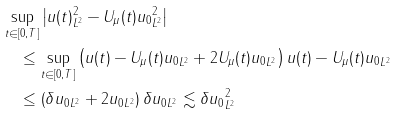<formula> <loc_0><loc_0><loc_500><loc_500>& \sup _ { t \in [ 0 , T ] } \left | \| u ( t ) \| _ { L ^ { 2 } } ^ { 2 } - \| U _ { \mu } ( t ) u _ { 0 } \| _ { L ^ { 2 } } ^ { 2 } \right | \\ & \quad \leq \sup _ { t \in [ 0 , T ] } \left ( \| u ( t ) - U _ { \mu } ( t ) u _ { 0 } \| _ { L ^ { 2 } } + 2 \| U _ { \mu } ( t ) u _ { 0 } \| _ { L ^ { 2 } } \right ) \| u ( t ) - U _ { \mu } ( t ) u _ { 0 } \| _ { L ^ { 2 } } \\ & \quad \leq \left ( \delta \| u _ { 0 } \| _ { L ^ { 2 } } + 2 \| u _ { 0 } \| _ { L ^ { 2 } } \right ) \delta \| u _ { 0 } \| _ { L ^ { 2 } } \lesssim \delta \| u _ { 0 } \| _ { L ^ { 2 } } ^ { 2 }</formula> 